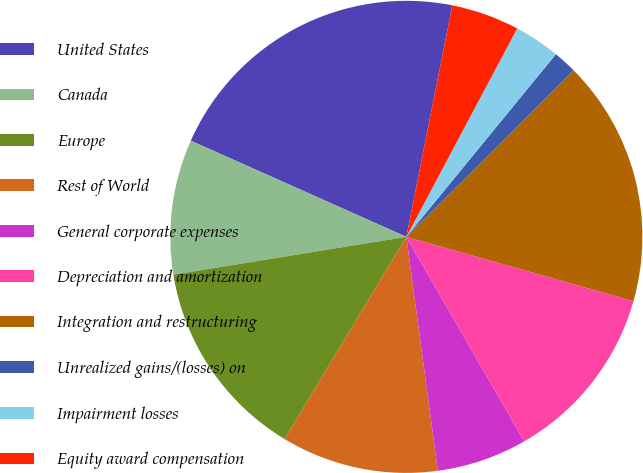Convert chart. <chart><loc_0><loc_0><loc_500><loc_500><pie_chart><fcel>United States<fcel>Canada<fcel>Europe<fcel>Rest of World<fcel>General corporate expenses<fcel>Depreciation and amortization<fcel>Integration and restructuring<fcel>Unrealized gains/(losses) on<fcel>Impairment losses<fcel>Equity award compensation<nl><fcel>21.44%<fcel>9.24%<fcel>13.81%<fcel>10.76%<fcel>6.19%<fcel>12.29%<fcel>16.86%<fcel>1.61%<fcel>3.14%<fcel>4.66%<nl></chart> 